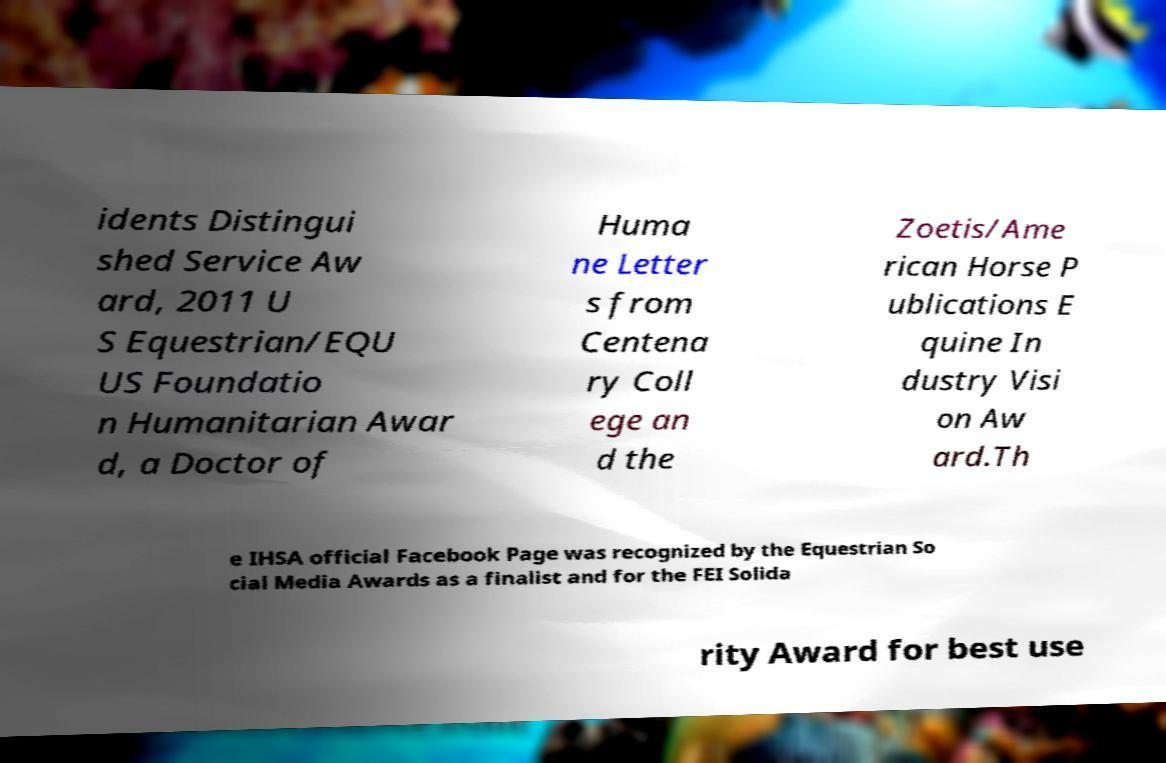There's text embedded in this image that I need extracted. Can you transcribe it verbatim? idents Distingui shed Service Aw ard, 2011 U S Equestrian/EQU US Foundatio n Humanitarian Awar d, a Doctor of Huma ne Letter s from Centena ry Coll ege an d the Zoetis/Ame rican Horse P ublications E quine In dustry Visi on Aw ard.Th e IHSA official Facebook Page was recognized by the Equestrian So cial Media Awards as a finalist and for the FEI Solida rity Award for best use 